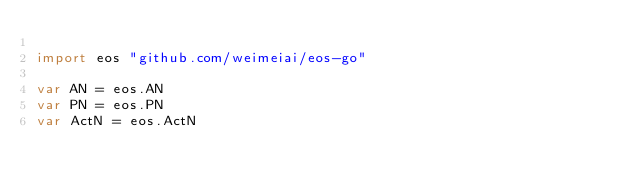Convert code to text. <code><loc_0><loc_0><loc_500><loc_500><_Go_>
import eos "github.com/weimeiai/eos-go"

var AN = eos.AN
var PN = eos.PN
var ActN = eos.ActN
</code> 